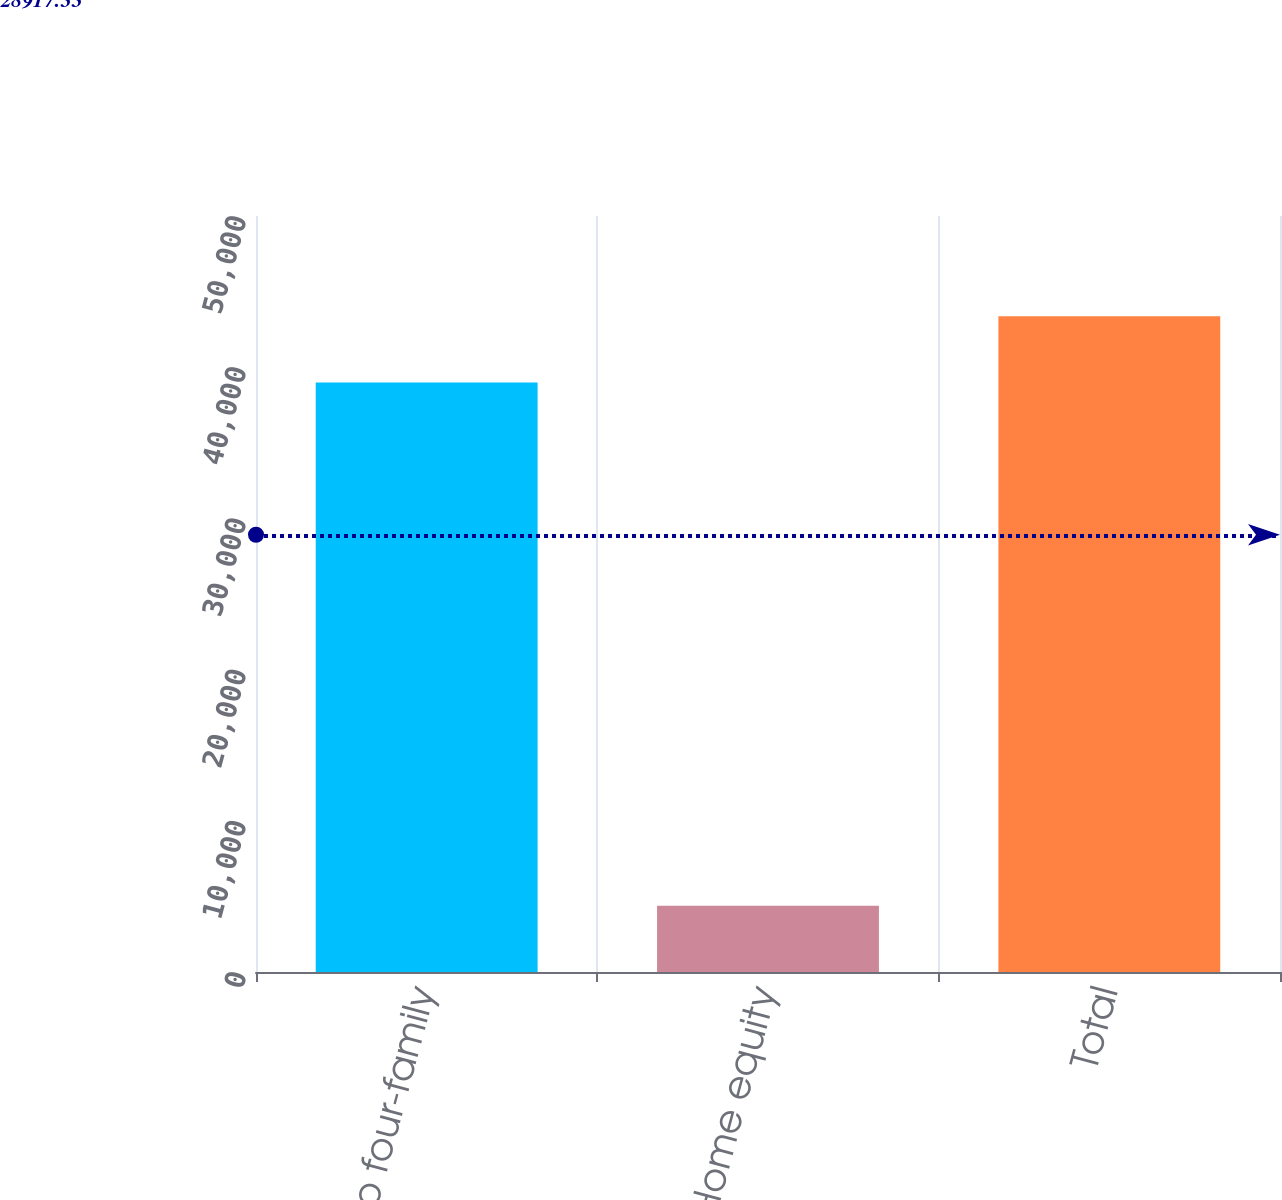Convert chart to OTSL. <chart><loc_0><loc_0><loc_500><loc_500><bar_chart><fcel>One- to four-family<fcel>Home equity<fcel>Total<nl><fcel>38987<fcel>4389<fcel>43376<nl></chart> 